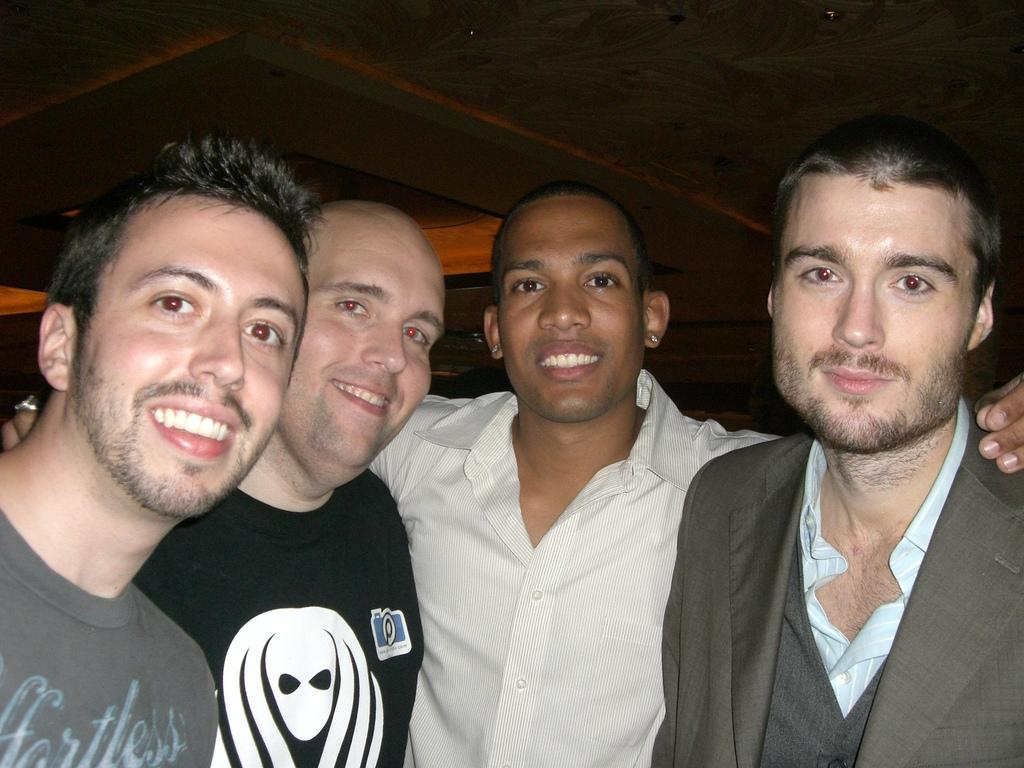How many people are in the image? There are four men in the image. What can be seen above the men in the image? There is a ceiling visible in the image. Can you describe any other objects present in the image? Unfortunately, the provided facts do not specify any other objects present in the image. What type of pest can be seen crawling on the carriage in the image? There is no carriage or pest present in the image; it only features four men and a ceiling. 